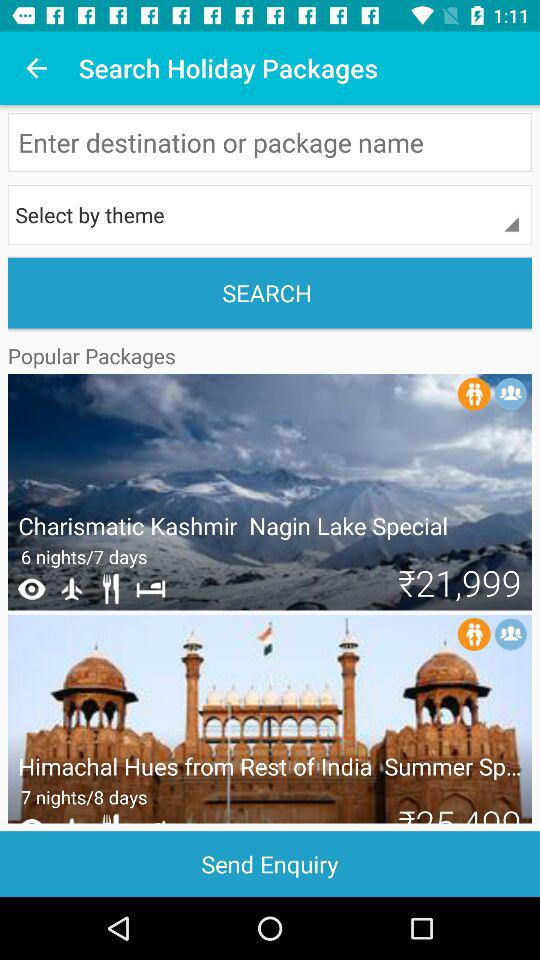What is the price of the "Charismatic Kashmir Nagin Lake Special" package? The "Charismatic Kashmir Nagin Lake Special" package is ₹21,999. 